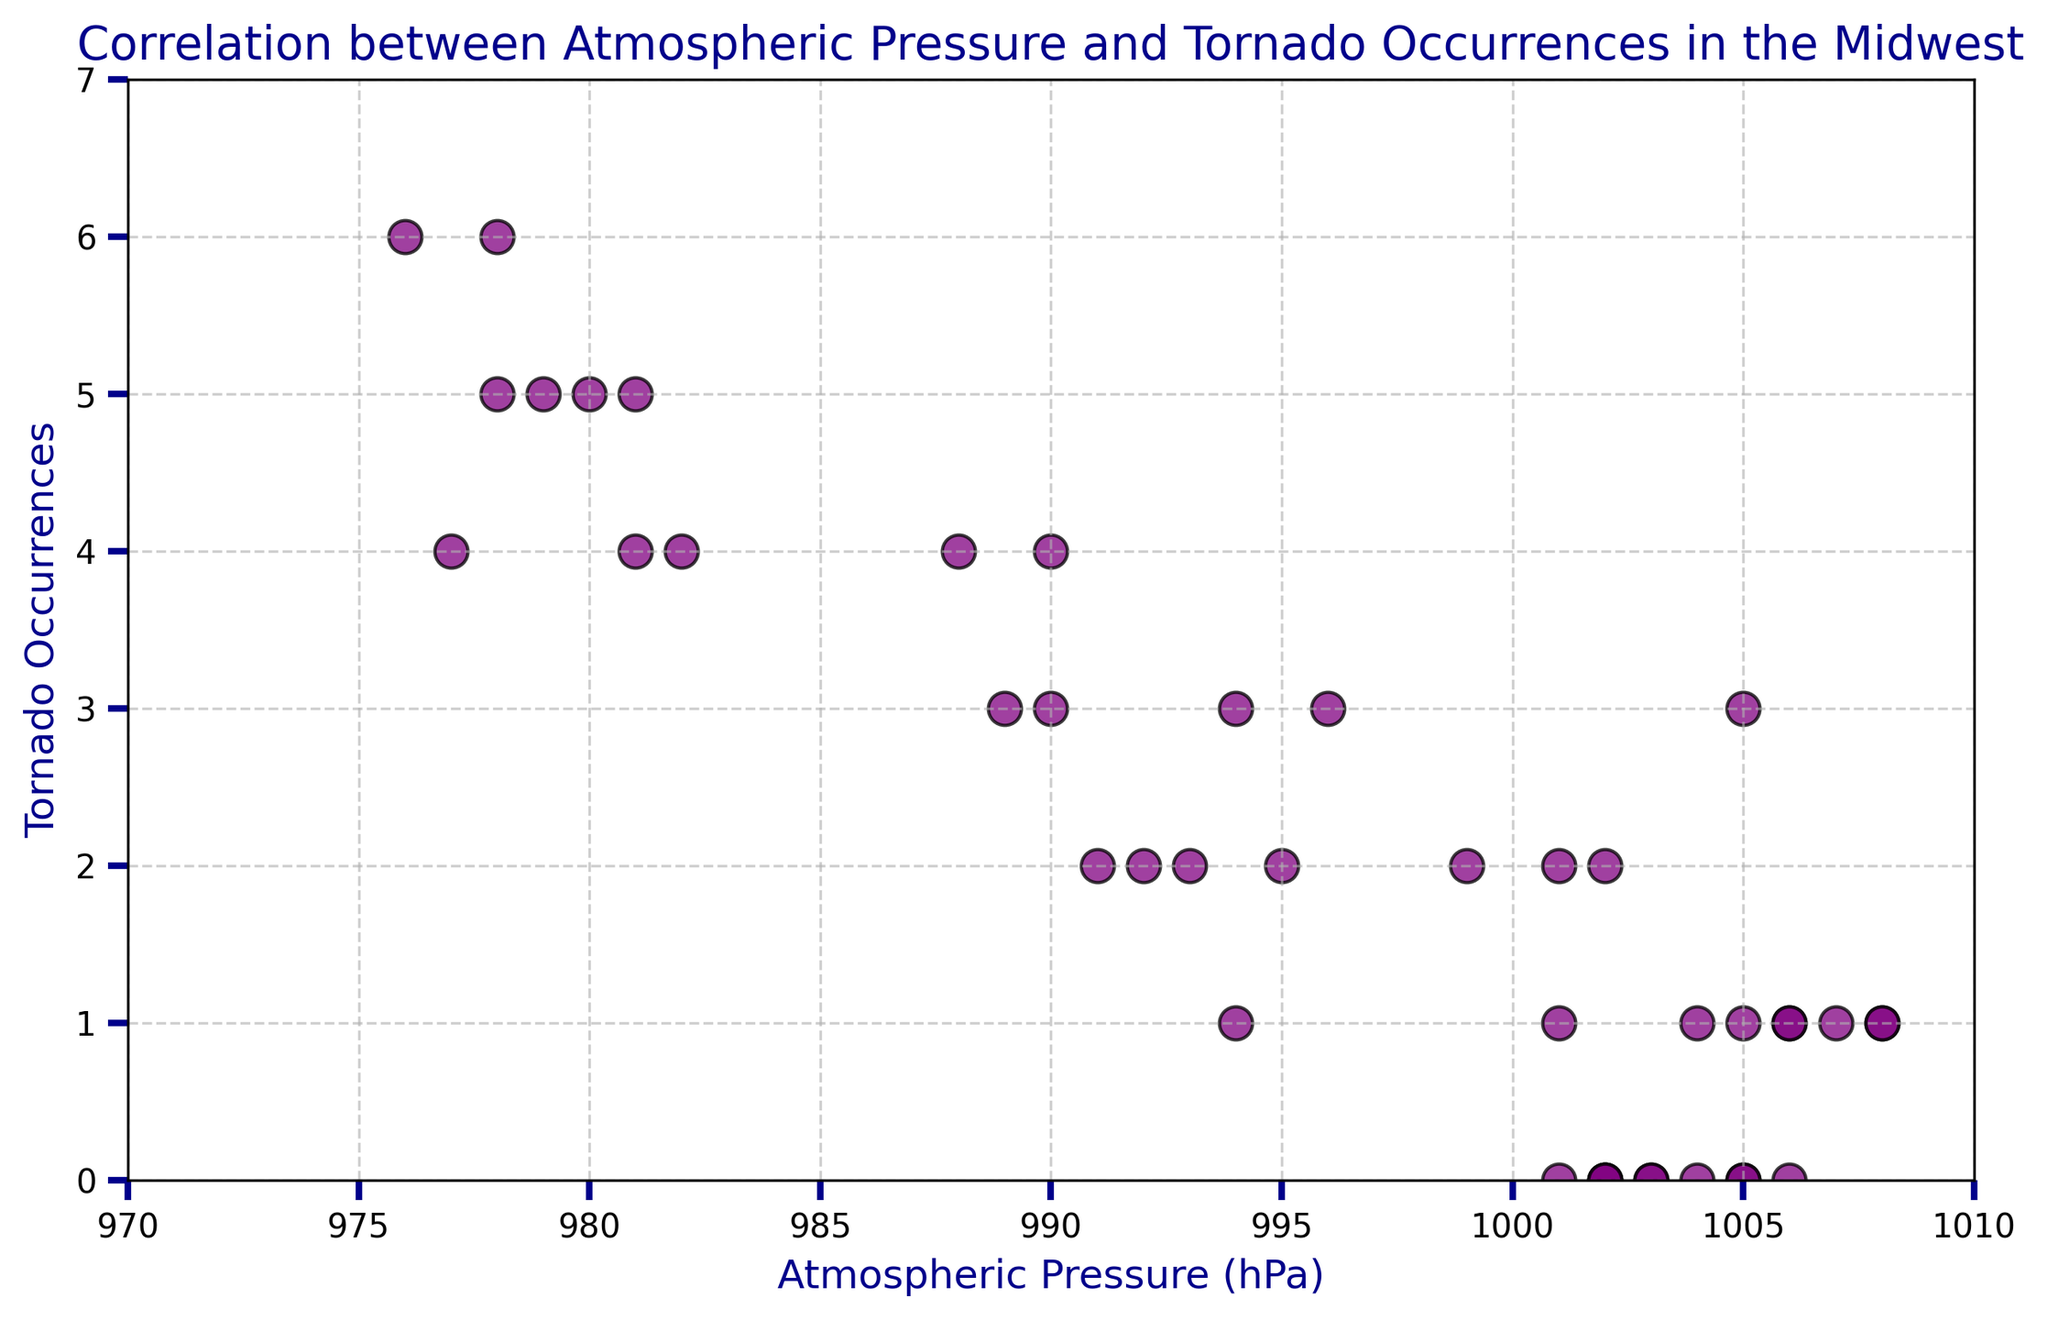How does the number of tornado occurrences change as atmospheric pressure decreases? To answer this, observe the scatter plot and note that as atmospheric pressure falls below 990 hPa, tornado occurrences tend to rise, indicating a negative correlation between atmospheric pressure and the number of tornadoes.
Answer: Tornado occurrences increase as atmospheric pressure decreases What is the atmospheric pressure accompanying the highest number of tornado occurrences, and how many occurrences were there? Identify the point with the highest y-value (tornado occurrences) on the scatter plot, which is 6 occurrences, and trace it to the corresponding atmospheric pressure around 976-978 hPa.
Answer: 976-978 hPa; 6 occurrences Compare the number of tornado occurrences at atmospheric pressures of 980 hPa and 1005 hPa. Which has more? Locate points around 980 hPa (5 occurrences) and 1005 hPa (0-3 occurrences) on the scatter plot. The occurrences around 980 hPa are generally higher than those at 1005 hPa.
Answer: 980 hPa What is the average number of tornado occurrences when atmospheric pressure is below 990 hPa? Sum tornado occurrences where atmospheric pressure < 990 hPa: (5 + 4 + 6 + 5 + 4)=24. Count the data points: 5. Compute the average: 24/5
Answer: 4.8 Between atmospheric pressures of 992, 993, and 994 hPa, what is the trend in tornado occurrences? Locate points at 992 hPa (2 occurrences), 993 hPa (2 occurrences), and 994 hPa (1, 3, 3 occurrences) to note that the tornado occurrences are relatively higher at 992 and 993 hPa compared to 994 hPa.
Answer: 992 and 993 hPa higher than 994 hPa 